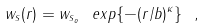<formula> <loc_0><loc_0><loc_500><loc_500>w _ { s } ( r ) = w _ { s _ { o } } \ e x p \{ - ( r / b ) ^ { \kappa } \} \ ,</formula> 